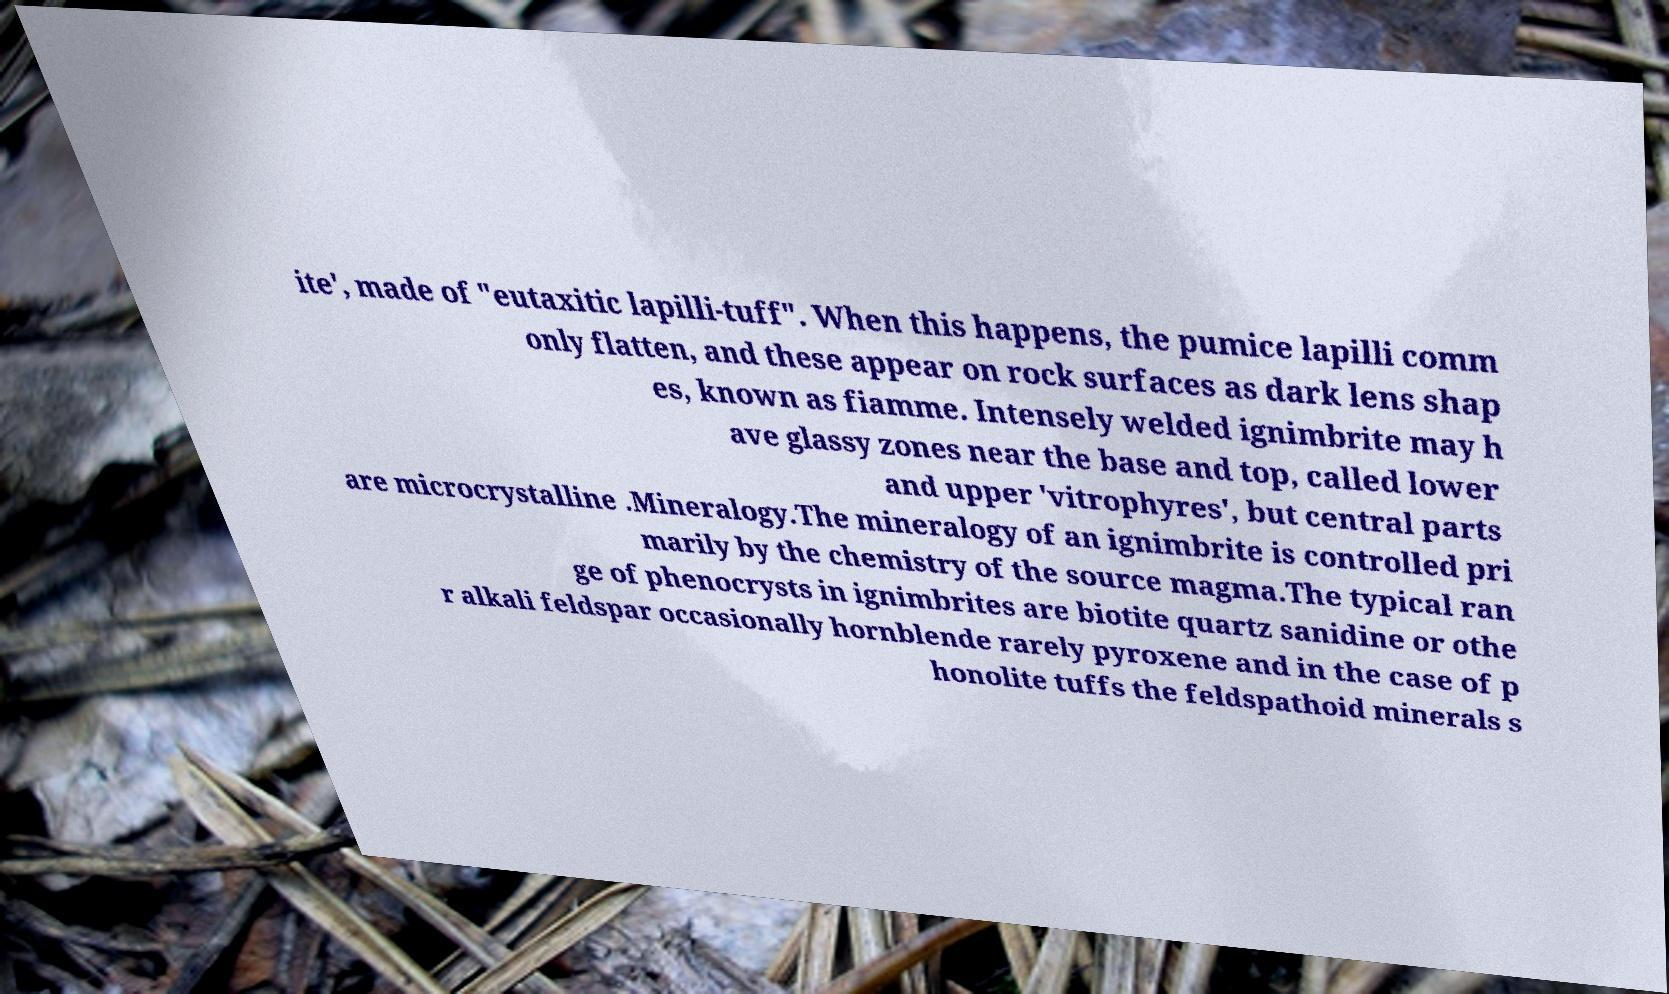Please read and relay the text visible in this image. What does it say? ite', made of "eutaxitic lapilli-tuff". When this happens, the pumice lapilli comm only flatten, and these appear on rock surfaces as dark lens shap es, known as fiamme. Intensely welded ignimbrite may h ave glassy zones near the base and top, called lower and upper 'vitrophyres', but central parts are microcrystalline .Mineralogy.The mineralogy of an ignimbrite is controlled pri marily by the chemistry of the source magma.The typical ran ge of phenocrysts in ignimbrites are biotite quartz sanidine or othe r alkali feldspar occasionally hornblende rarely pyroxene and in the case of p honolite tuffs the feldspathoid minerals s 